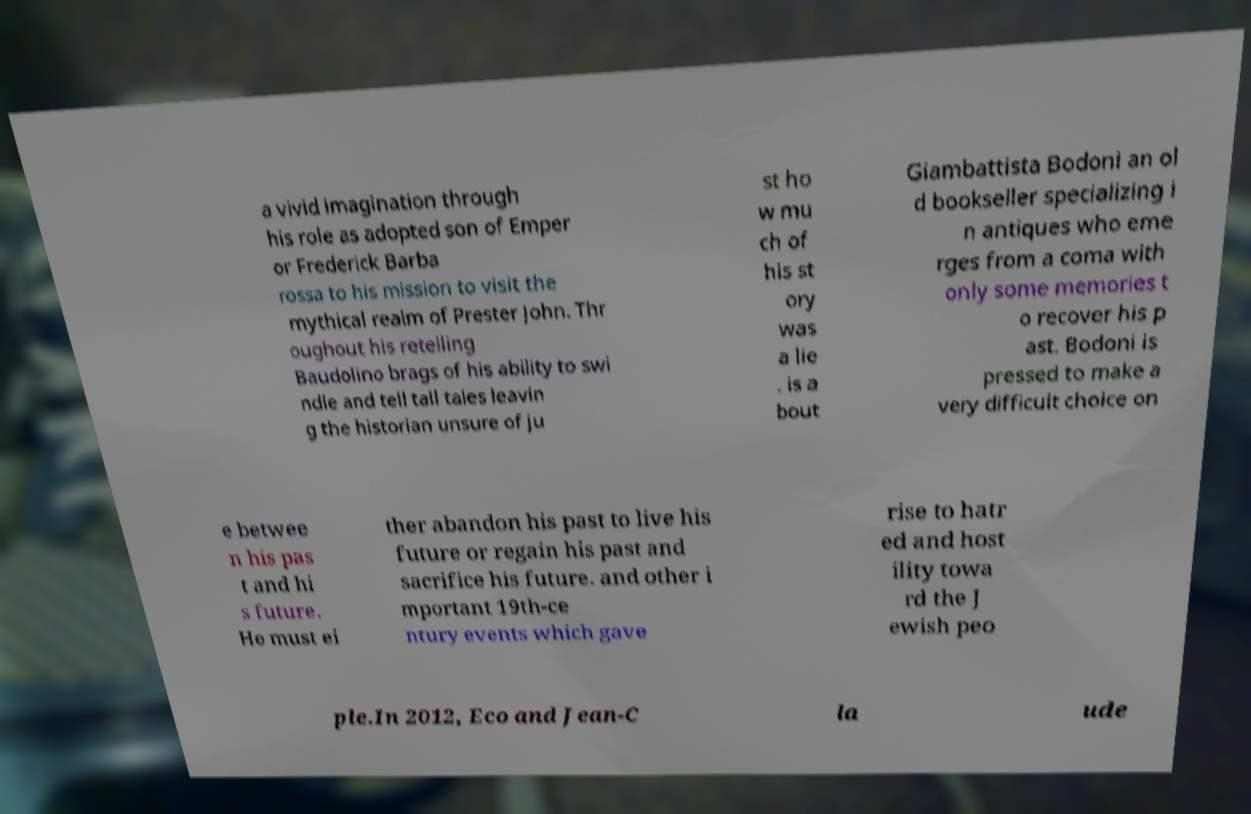What messages or text are displayed in this image? I need them in a readable, typed format. a vivid imagination through his role as adopted son of Emper or Frederick Barba rossa to his mission to visit the mythical realm of Prester John. Thr oughout his retelling Baudolino brags of his ability to swi ndle and tell tall tales leavin g the historian unsure of ju st ho w mu ch of his st ory was a lie . is a bout Giambattista Bodoni an ol d bookseller specializing i n antiques who eme rges from a coma with only some memories t o recover his p ast. Bodoni is pressed to make a very difficult choice on e betwee n his pas t and hi s future. He must ei ther abandon his past to live his future or regain his past and sacrifice his future. and other i mportant 19th-ce ntury events which gave rise to hatr ed and host ility towa rd the J ewish peo ple.In 2012, Eco and Jean-C la ude 